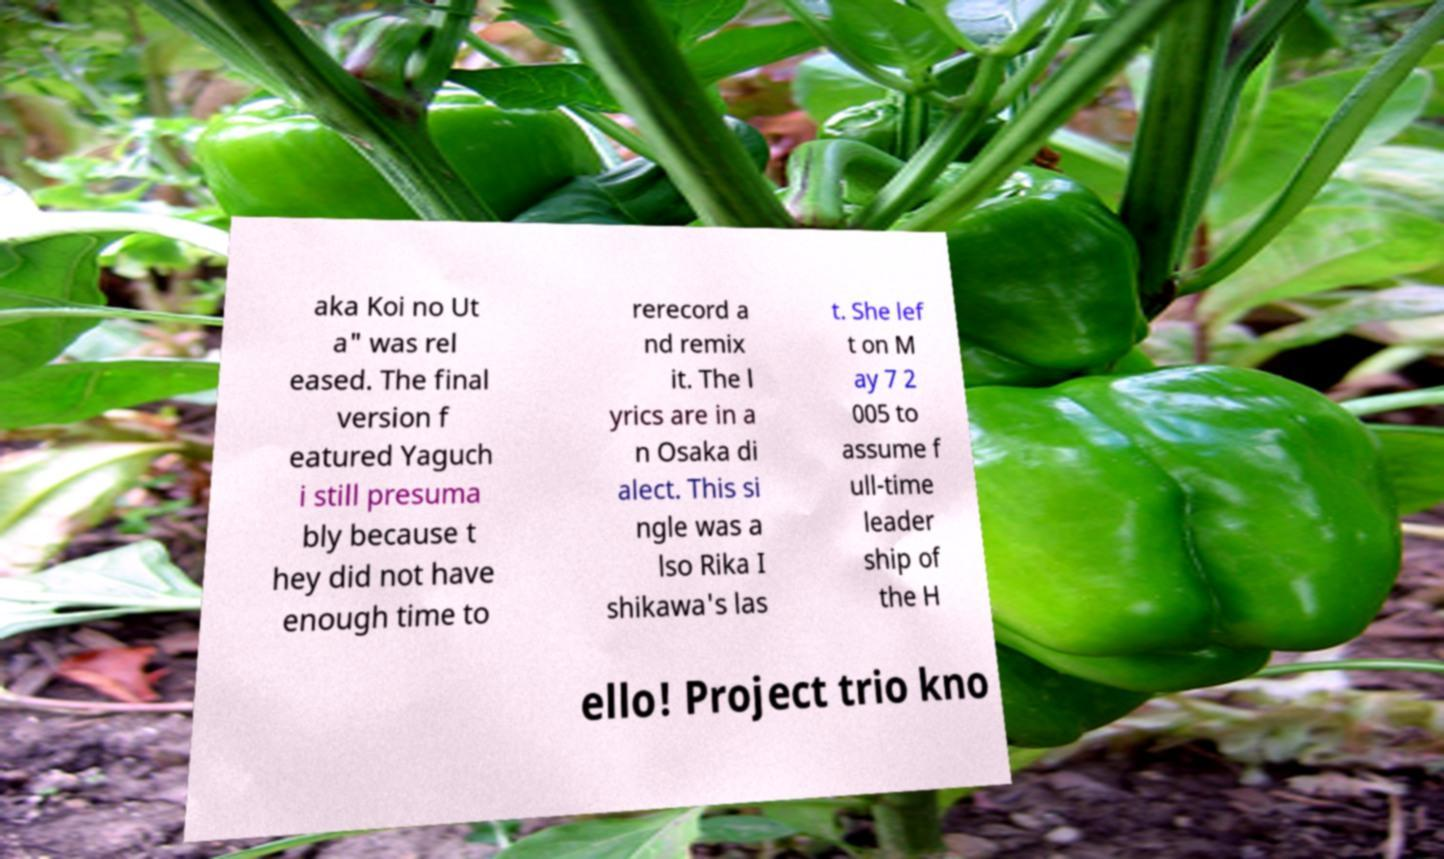Can you read and provide the text displayed in the image?This photo seems to have some interesting text. Can you extract and type it out for me? aka Koi no Ut a" was rel eased. The final version f eatured Yaguch i still presuma bly because t hey did not have enough time to rerecord a nd remix it. The l yrics are in a n Osaka di alect. This si ngle was a lso Rika I shikawa's las t. She lef t on M ay 7 2 005 to assume f ull-time leader ship of the H ello! Project trio kno 